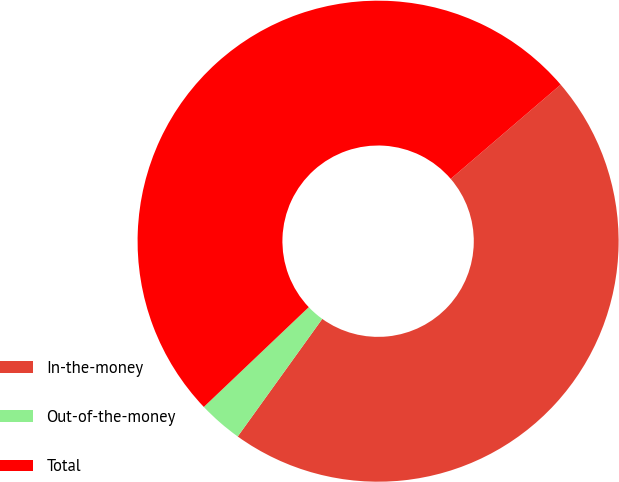Convert chart to OTSL. <chart><loc_0><loc_0><loc_500><loc_500><pie_chart><fcel>In-the-money<fcel>Out-of-the-money<fcel>Total<nl><fcel>46.2%<fcel>2.98%<fcel>50.82%<nl></chart> 